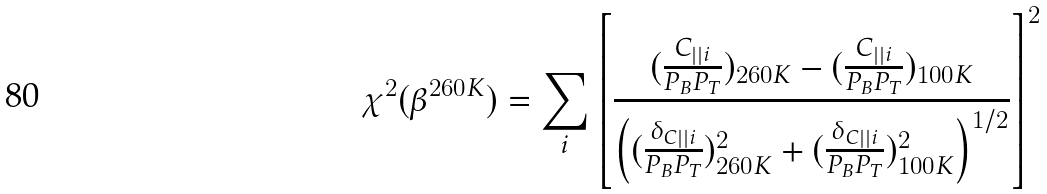Convert formula to latex. <formula><loc_0><loc_0><loc_500><loc_500>\chi ^ { 2 } ( \beta ^ { 2 6 0 K } ) = \sum _ { i } \left [ \frac { ( \frac { C _ { | | i } } { P _ { B } P _ { T } } ) _ { 2 6 0 K } - ( \frac { C _ { | | i } } { P _ { B } P _ { T } } ) _ { 1 0 0 K } } { \left ( ( \frac { \delta _ { C | | i } } { P _ { B } P _ { T } } ) ^ { 2 } _ { 2 6 0 K } + ( \frac { \delta _ { C | | i } } { P _ { B } P _ { T } } ) ^ { 2 } _ { 1 0 0 K } \right ) ^ { 1 / 2 } } \right ] ^ { 2 }</formula> 